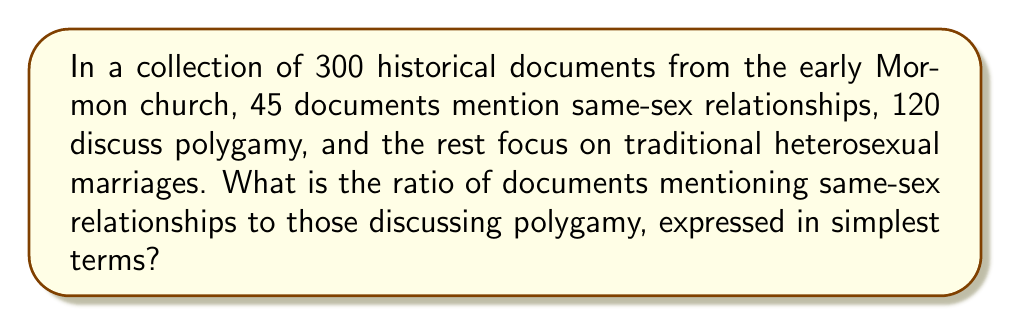Can you solve this math problem? To solve this problem, we need to follow these steps:

1. Identify the number of documents for each category:
   - Same-sex relationships: 45
   - Polygamy: 120
   - Traditional heterosexual marriages: 300 - (45 + 120) = 135

2. Set up the ratio of same-sex relationships to polygamy:
   $\frac{45}{120}$

3. Simplify the ratio by finding the greatest common divisor (GCD) of 45 and 120:
   $GCD(45, 120) = 15$

4. Divide both the numerator and denominator by the GCD:
   $\frac{45 \div 15}{120 \div 15} = \frac{3}{8}$

Therefore, the simplified ratio of documents mentioning same-sex relationships to those discussing polygamy is 3:8.
Answer: $3:8$ 